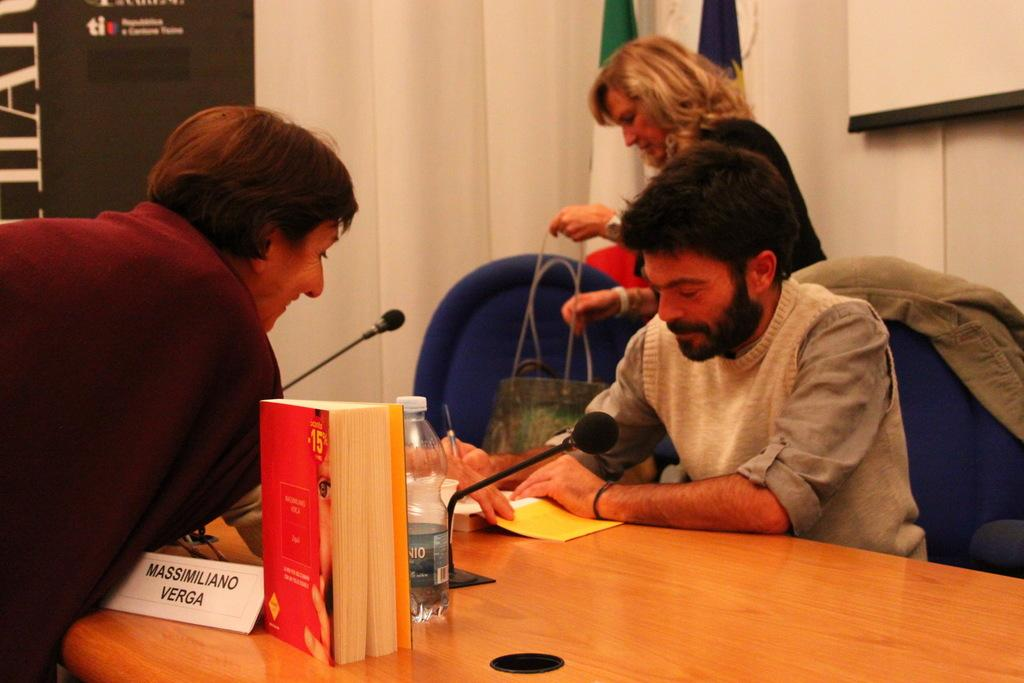<image>
Share a concise interpretation of the image provided. A man leans over a desk towards him as Massimiliano Verga signs his book. 